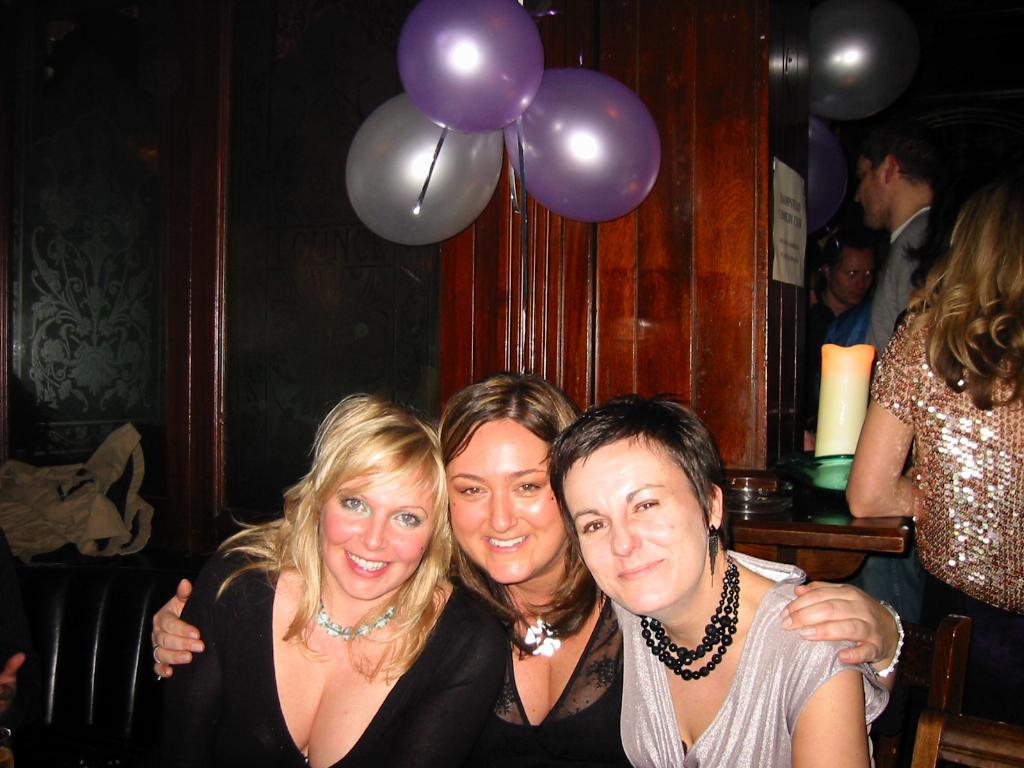Please provide a concise description of this image. At the bottom of the image, we can see three women are sitting side by side. They are watching and smiling. On the right side, we can see few people, table and some objects. Background we can see glass wooden object, poster and balloons. Left side of the image, we can see human hand and cloth. 